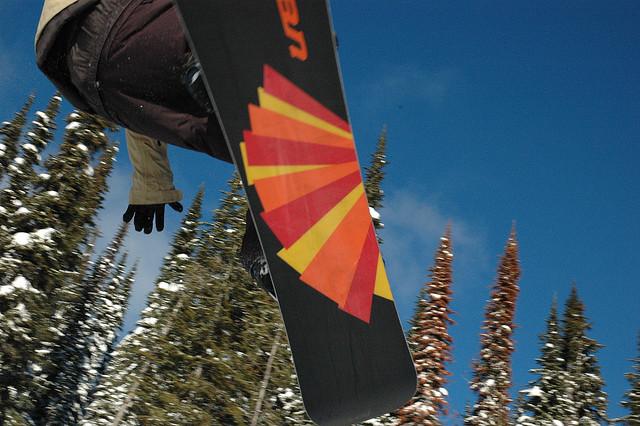How many kites are there?
Keep it brief. 0. What is the snowboarder doing?
Answer briefly. Jumping. What letter is on the red flag?
Give a very brief answer. N. Is the snowboarder wearing gloves?
Give a very brief answer. Yes. 